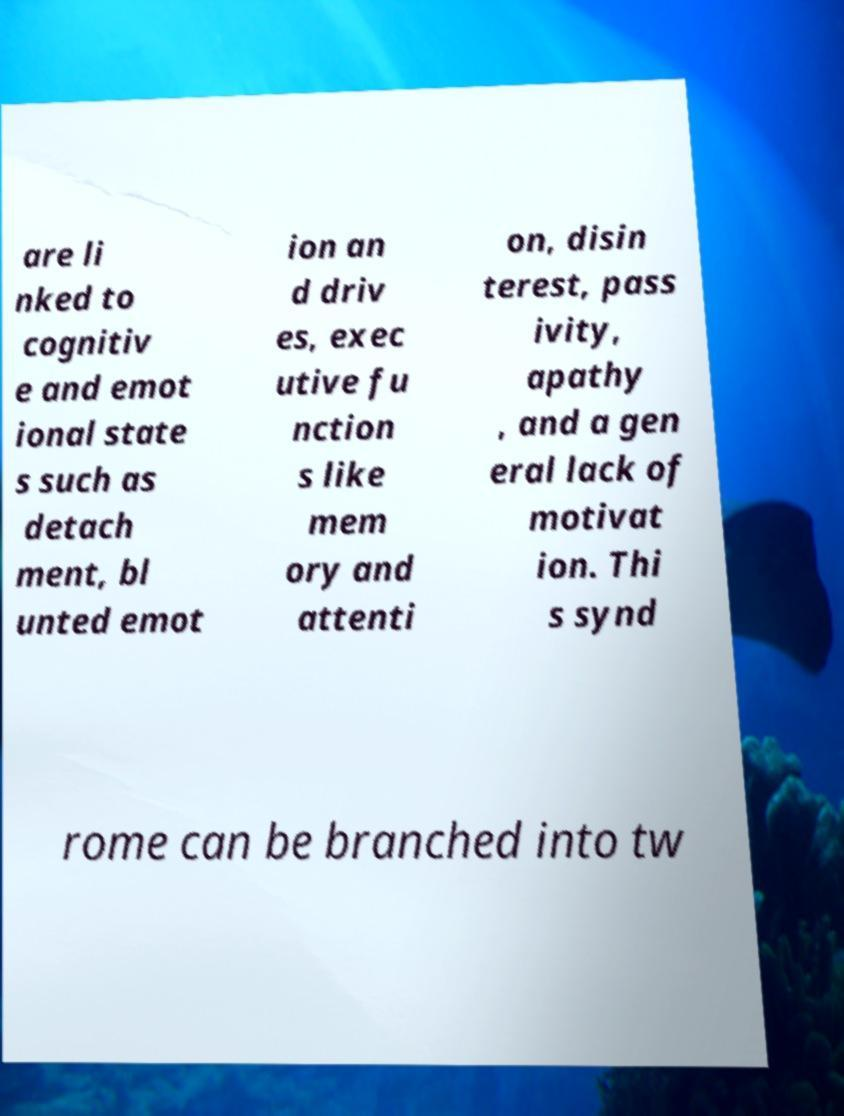I need the written content from this picture converted into text. Can you do that? are li nked to cognitiv e and emot ional state s such as detach ment, bl unted emot ion an d driv es, exec utive fu nction s like mem ory and attenti on, disin terest, pass ivity, apathy , and a gen eral lack of motivat ion. Thi s synd rome can be branched into tw 